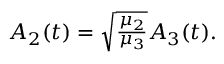Convert formula to latex. <formula><loc_0><loc_0><loc_500><loc_500>\begin{array} { r } { A _ { 2 } ( t ) = \sqrt { \frac { \mu _ { 2 } } { \mu _ { 3 } } } A _ { 3 } ( t ) . } \end{array}</formula> 